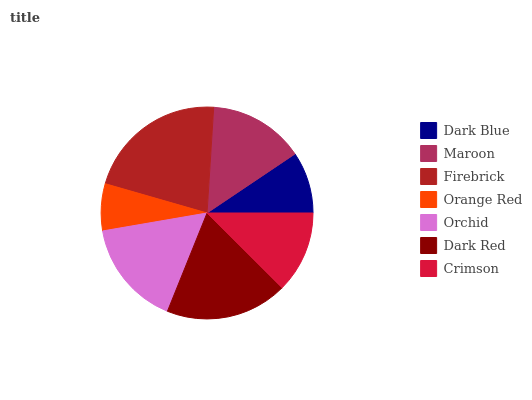Is Orange Red the minimum?
Answer yes or no. Yes. Is Firebrick the maximum?
Answer yes or no. Yes. Is Maroon the minimum?
Answer yes or no. No. Is Maroon the maximum?
Answer yes or no. No. Is Maroon greater than Dark Blue?
Answer yes or no. Yes. Is Dark Blue less than Maroon?
Answer yes or no. Yes. Is Dark Blue greater than Maroon?
Answer yes or no. No. Is Maroon less than Dark Blue?
Answer yes or no. No. Is Maroon the high median?
Answer yes or no. Yes. Is Maroon the low median?
Answer yes or no. Yes. Is Dark Red the high median?
Answer yes or no. No. Is Orange Red the low median?
Answer yes or no. No. 